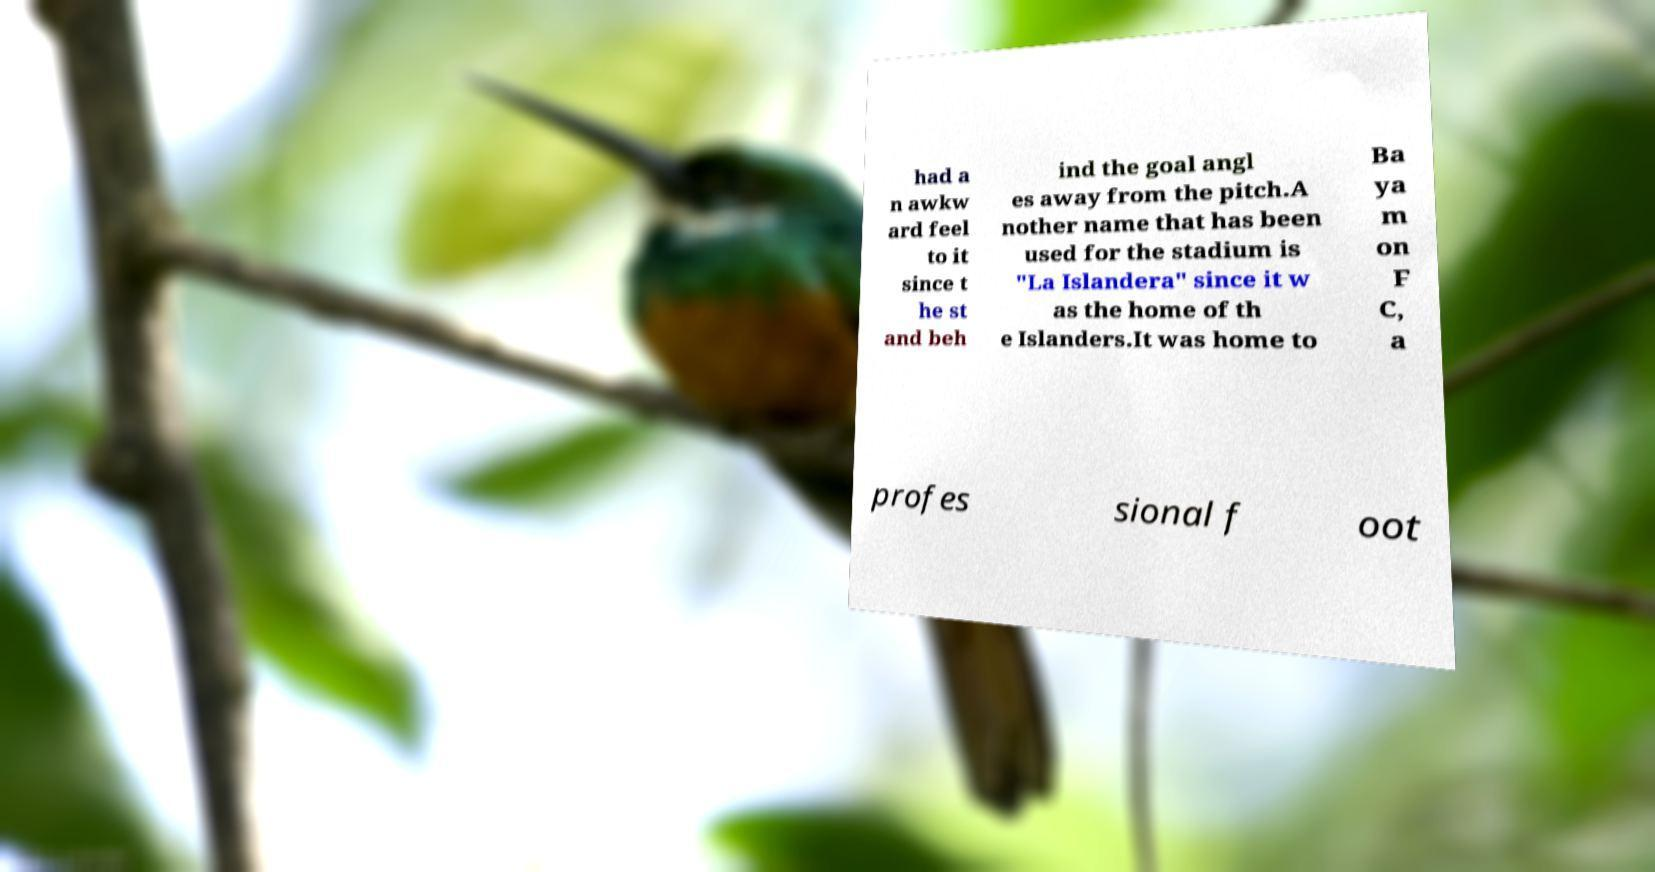Could you assist in decoding the text presented in this image and type it out clearly? had a n awkw ard feel to it since t he st and beh ind the goal angl es away from the pitch.A nother name that has been used for the stadium is "La Islandera" since it w as the home of th e Islanders.It was home to Ba ya m on F C, a profes sional f oot 